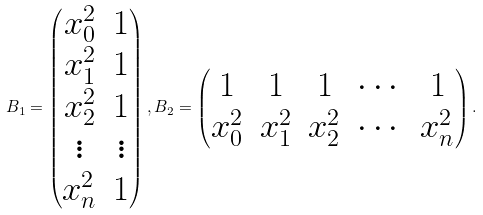Convert formula to latex. <formula><loc_0><loc_0><loc_500><loc_500>B _ { 1 } = \begin{pmatrix} x _ { 0 } ^ { 2 } & 1 \\ x _ { 1 } ^ { 2 } & 1 \\ x _ { 2 } ^ { 2 } & 1 \\ \vdots & \vdots \\ x _ { n } ^ { 2 } & 1 \\ \end{pmatrix} , B _ { 2 } = \begin{pmatrix} 1 & 1 & 1 & \cdots & 1 \\ x _ { 0 } ^ { 2 } & x _ { 1 } ^ { 2 } & x _ { 2 } ^ { 2 } & \cdots & x _ { n } ^ { 2 } \\ \end{pmatrix} .</formula> 